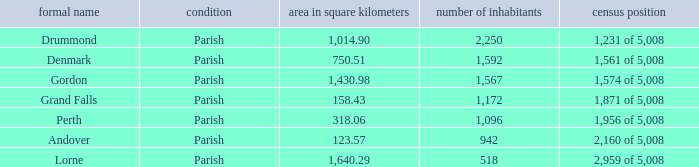Which parish has an area of 750.51? Denmark. 